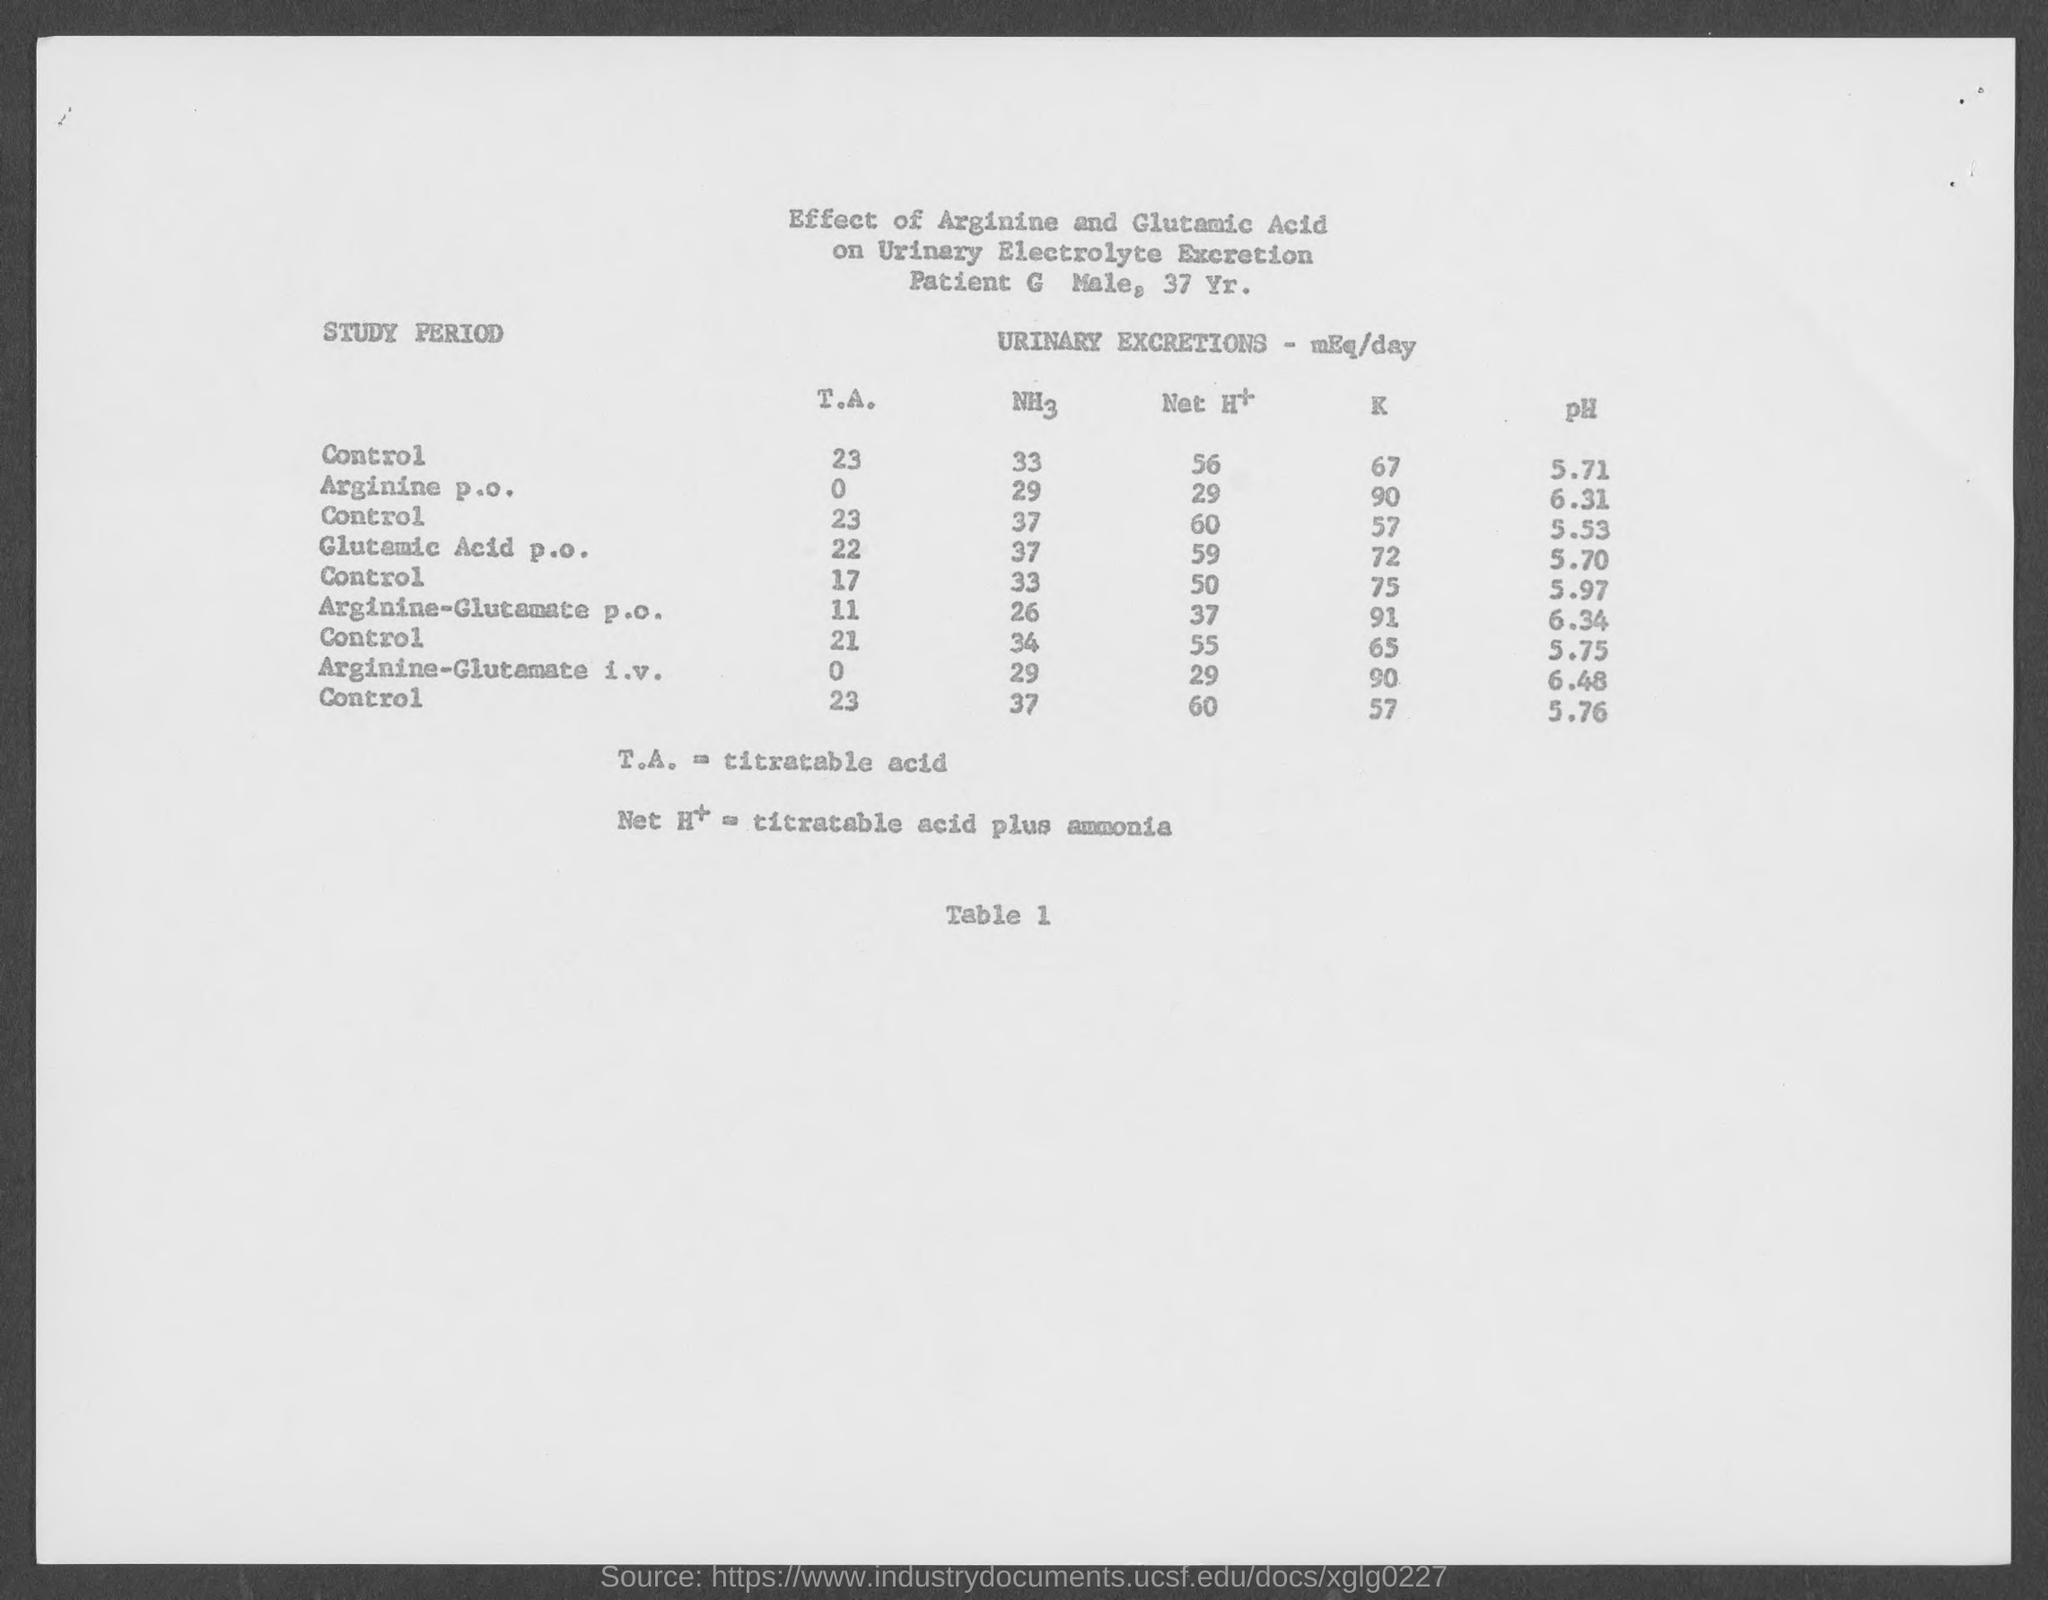What is the table number?
Offer a very short reply. Table 1. What is the full form of TA?
Make the answer very short. Titratable acid. What is the age of the patient?
Your answer should be compact. 37. What is the sex of the patient?
Ensure brevity in your answer.  Male. What is the pH of Arginine p.o.?
Keep it short and to the point. 6.31. What is the pH of Arginine-Glutamate p.o.?
Give a very brief answer. 6.34. 